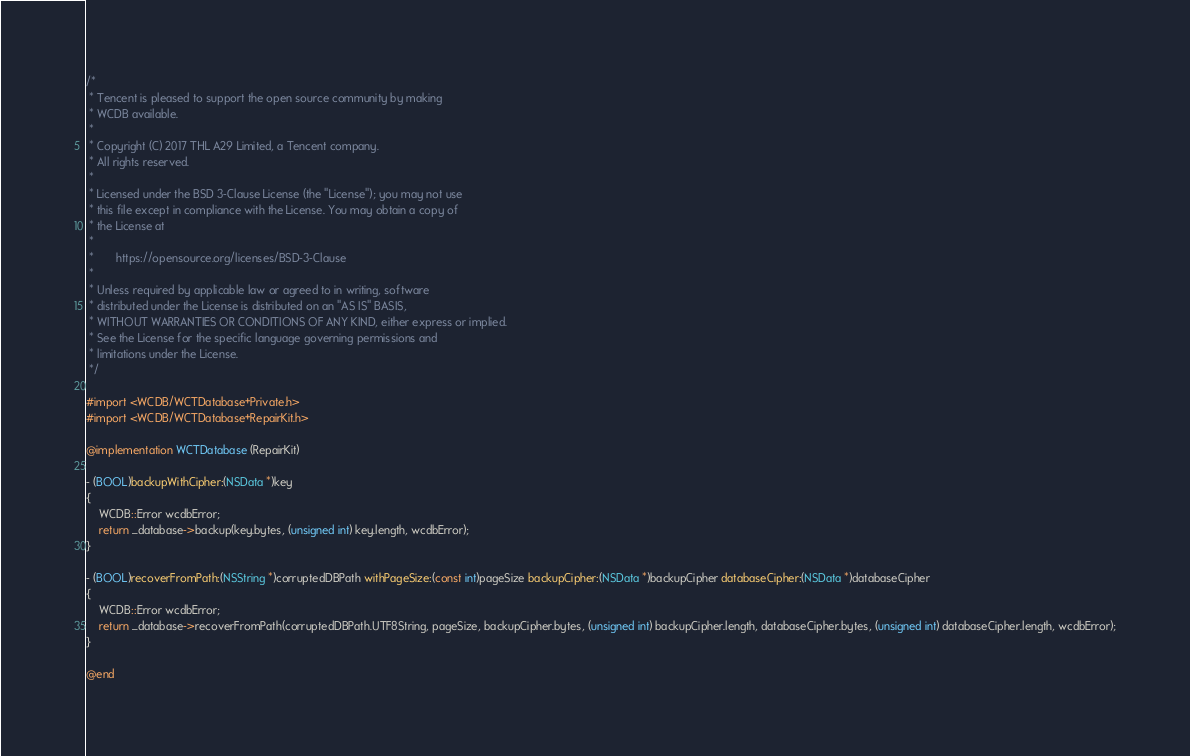<code> <loc_0><loc_0><loc_500><loc_500><_ObjectiveC_>/*
 * Tencent is pleased to support the open source community by making
 * WCDB available.
 *
 * Copyright (C) 2017 THL A29 Limited, a Tencent company.
 * All rights reserved.
 *
 * Licensed under the BSD 3-Clause License (the "License"); you may not use
 * this file except in compliance with the License. You may obtain a copy of
 * the License at
 *
 *       https://opensource.org/licenses/BSD-3-Clause
 *
 * Unless required by applicable law or agreed to in writing, software
 * distributed under the License is distributed on an "AS IS" BASIS,
 * WITHOUT WARRANTIES OR CONDITIONS OF ANY KIND, either express or implied.
 * See the License for the specific language governing permissions and
 * limitations under the License.
 */

#import <WCDB/WCTDatabase+Private.h>
#import <WCDB/WCTDatabase+RepairKit.h>

@implementation WCTDatabase (RepairKit)

- (BOOL)backupWithCipher:(NSData *)key
{
    WCDB::Error wcdbError;
    return _database->backup(key.bytes, (unsigned int) key.length, wcdbError);
}

- (BOOL)recoverFromPath:(NSString *)corruptedDBPath withPageSize:(const int)pageSize backupCipher:(NSData *)backupCipher databaseCipher:(NSData *)databaseCipher
{
    WCDB::Error wcdbError;
    return _database->recoverFromPath(corruptedDBPath.UTF8String, pageSize, backupCipher.bytes, (unsigned int) backupCipher.length, databaseCipher.bytes, (unsigned int) databaseCipher.length, wcdbError);
}

@end
</code> 